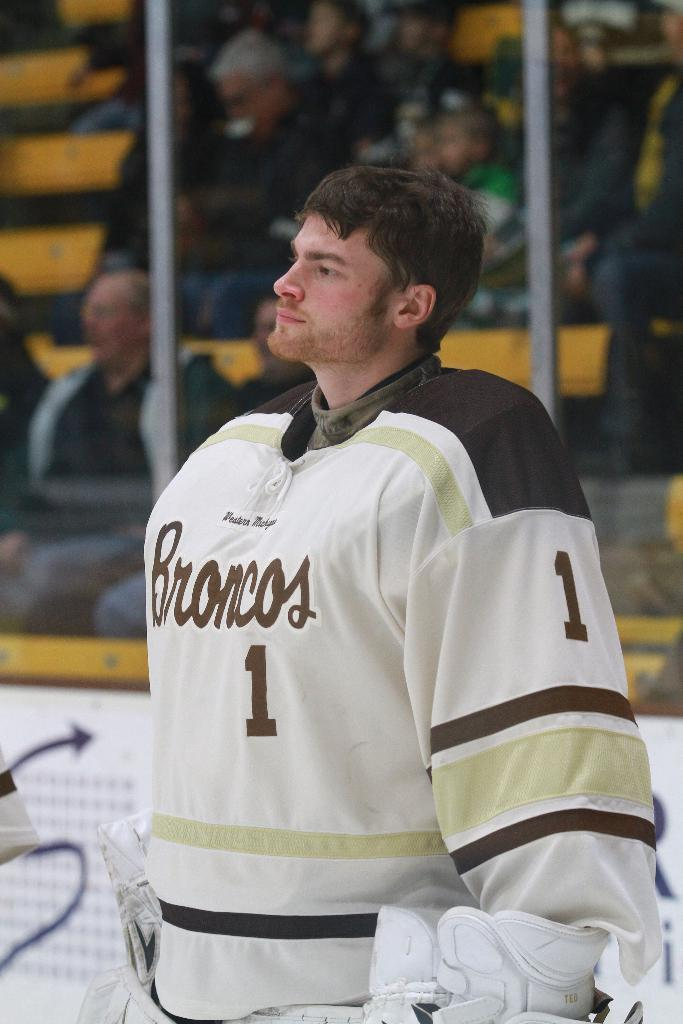What is the man in the image wearing? The man in the image is wearing a costume. What can be seen behind the man? There is a poster behind the man. What is behind the poster? There are rods behind the poster. What is happening behind the rods? There are people sitting behind the rods. What shape is the bucket in the image? There is no bucket present in the image. 